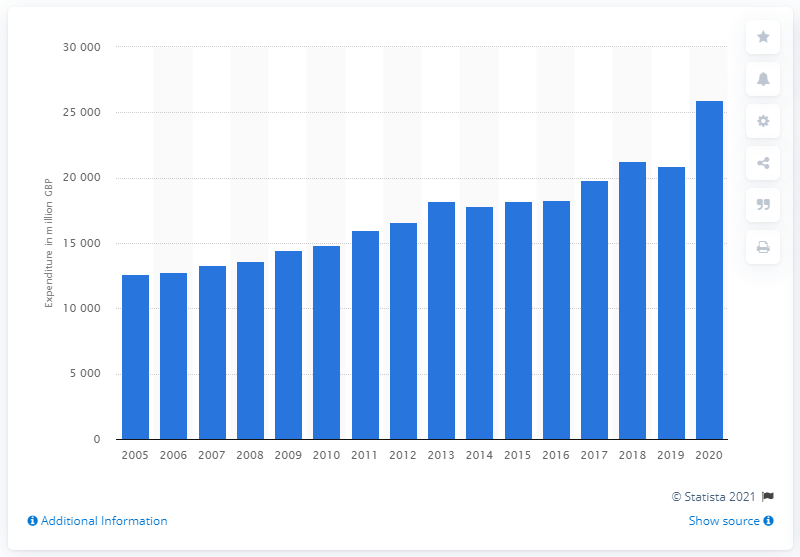Mention a couple of crucial points in this snapshot. In 2020, the United Kingdom spent approximately 25,964 British pounds on alcoholic drinks. 